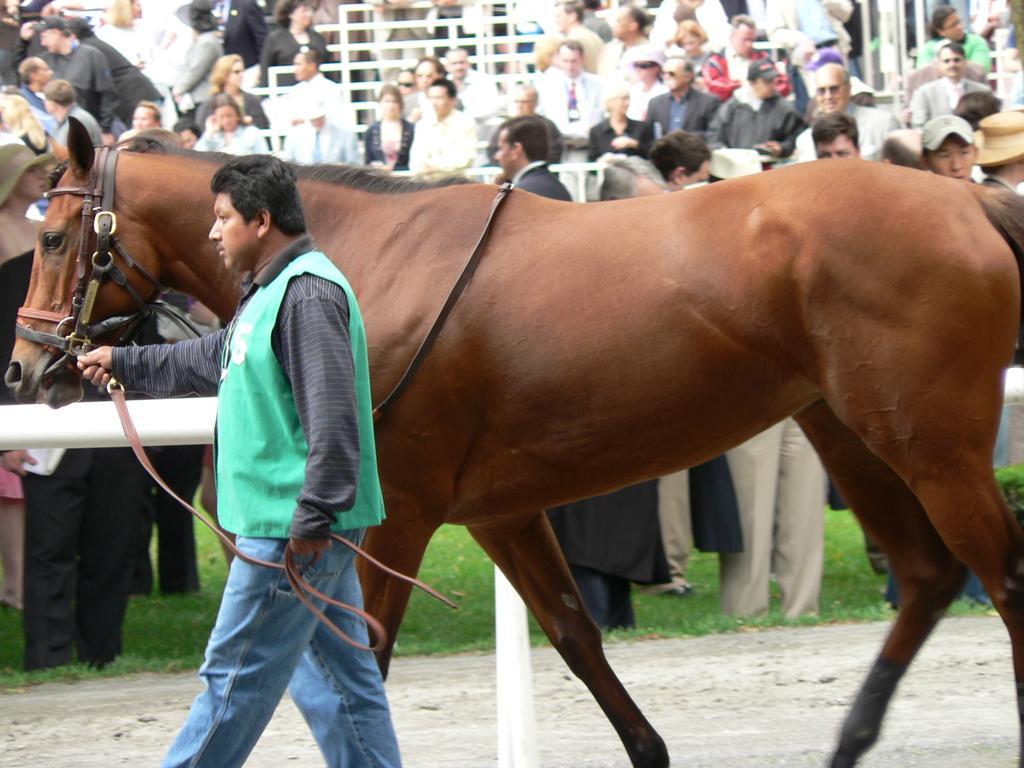Can you describe this image briefly? In this picture we can see man wore jacket holding horse with rope and in background we can see crowd of people and fence here we can see grass, land. 